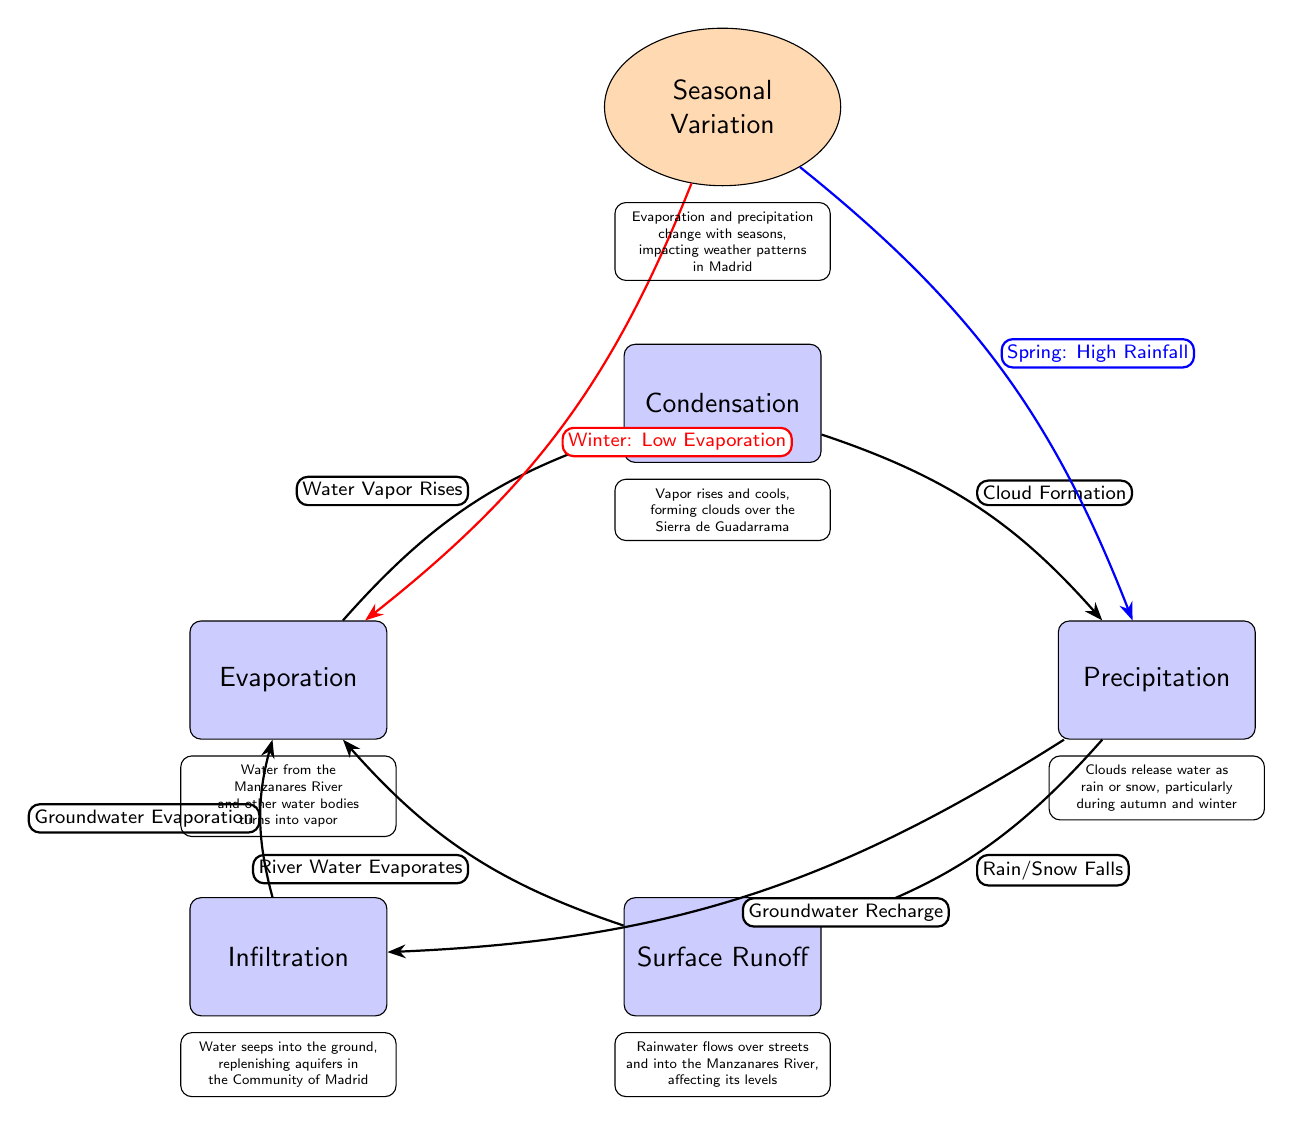What is the first process in the water cycle? The diagram identifies the first process in the water cycle as "Evaporation," which is labeled at the top left of the diagram.
Answer: Evaporation How many main processes are represented in the diagram? Counting all the distinct process nodes shown, there are five main processes in the diagram: Evaporation, Condensation, Precipitation, Surface Runoff, and Infiltration.
Answer: Five What causes water vapor to rise? According to the diagram, the transition from Evaporation to Condensation indicates that water from the Manzanares River and other water bodies turns into vapor, which naturally rises.
Answer: Water from the Manzanares River and other water bodies What is the relationship between precipitation and surface runoff? The diagram illustrates a direct flow from the Precipitation node to the Surface Runoff node, showing that rainfall directly contributes to water flowing over streets into rivers.
Answer: Rainfall contributes to water flowing over streets Which season is associated with low evaporation? The seasonal variation node indicates that during Winter, there is "Low Evaporation," which is emphasized with a red thick arrow leading to the Evaporation process.
Answer: Winter What does groundwater infiltration contribute to? The diagram indicates that Infiltration leads to groundwater recharge, therefore when water seeps into the ground, it replenishes aquifers in the Community of Madrid.
Answer: Groundwater recharge What happens to the water after surface runoff? The diagram flows from Surface Runoff back to the Evaporation process, indicating that the water flowing into rivers eventually evaporates again.
Answer: River Water Evaporates Which seasonal variation indicates high rainfall? The blue thick arrow connects the seasonal variation to the Precipitation process, indicating that Spring is associated with "High Rainfall."
Answer: Spring How do clouds form according to the diagram? The flow from Evaporation to Condensation signifies that vapor rises and cools, which then leads to cloud formation.
Answer: Vapor rises and cools 